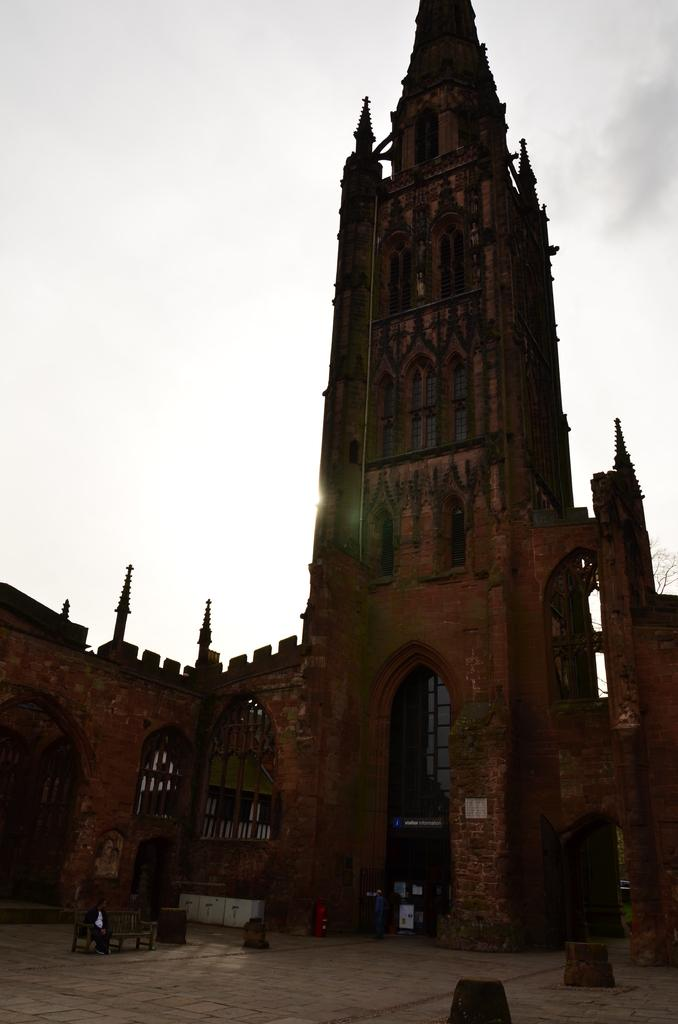What type of structure is visible in the image? There is a building in the image. What natural element can be seen in the image? There is a tree in the image. What type of seating is present at the bottom of the image? There is a bench at the bottom of the image. What material is present on the road in the image? Stones are present on the road in the image. What else can be seen on the road in the image? There are objects on the road in the image. What is visible at the top of the image? The sky is visible at the top of the image. How many jellyfish are swimming in the sky in the image? There are no jellyfish present in the image, and the sky is not a body of water where jellyfish would be found. What type of vehicles are driving on the road in the image? There is no mention of vehicles, specifically trucks, in the provided facts about the image. 